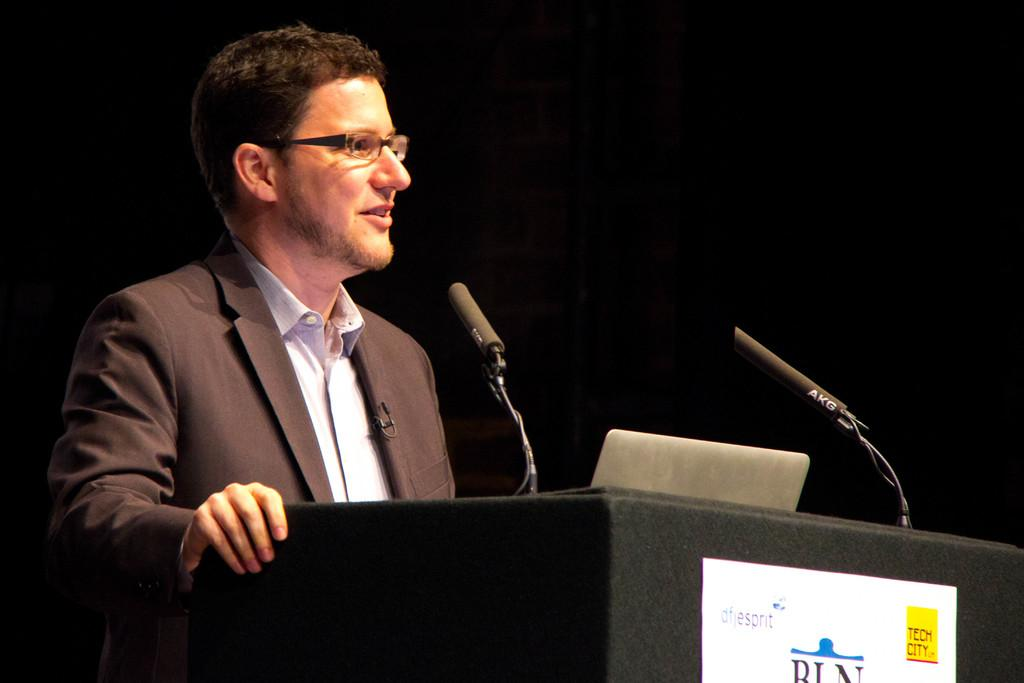Who is the main subject in the image? There is a man in the image. What is the man wearing? The man is wearing a suit. What is the man doing in the image? The man is standing in front of a podium and talking into a microphone. What is on the podium? There is a paper on the podium. How would you describe the background of the image? The background of the image is dark. What type of copper tub can be seen in the image? There is no copper tub present in the image. How does the man's cough affect his speech in the image? There is no mention of the man coughing in the image, so it cannot be determined how it would affect his speech. 